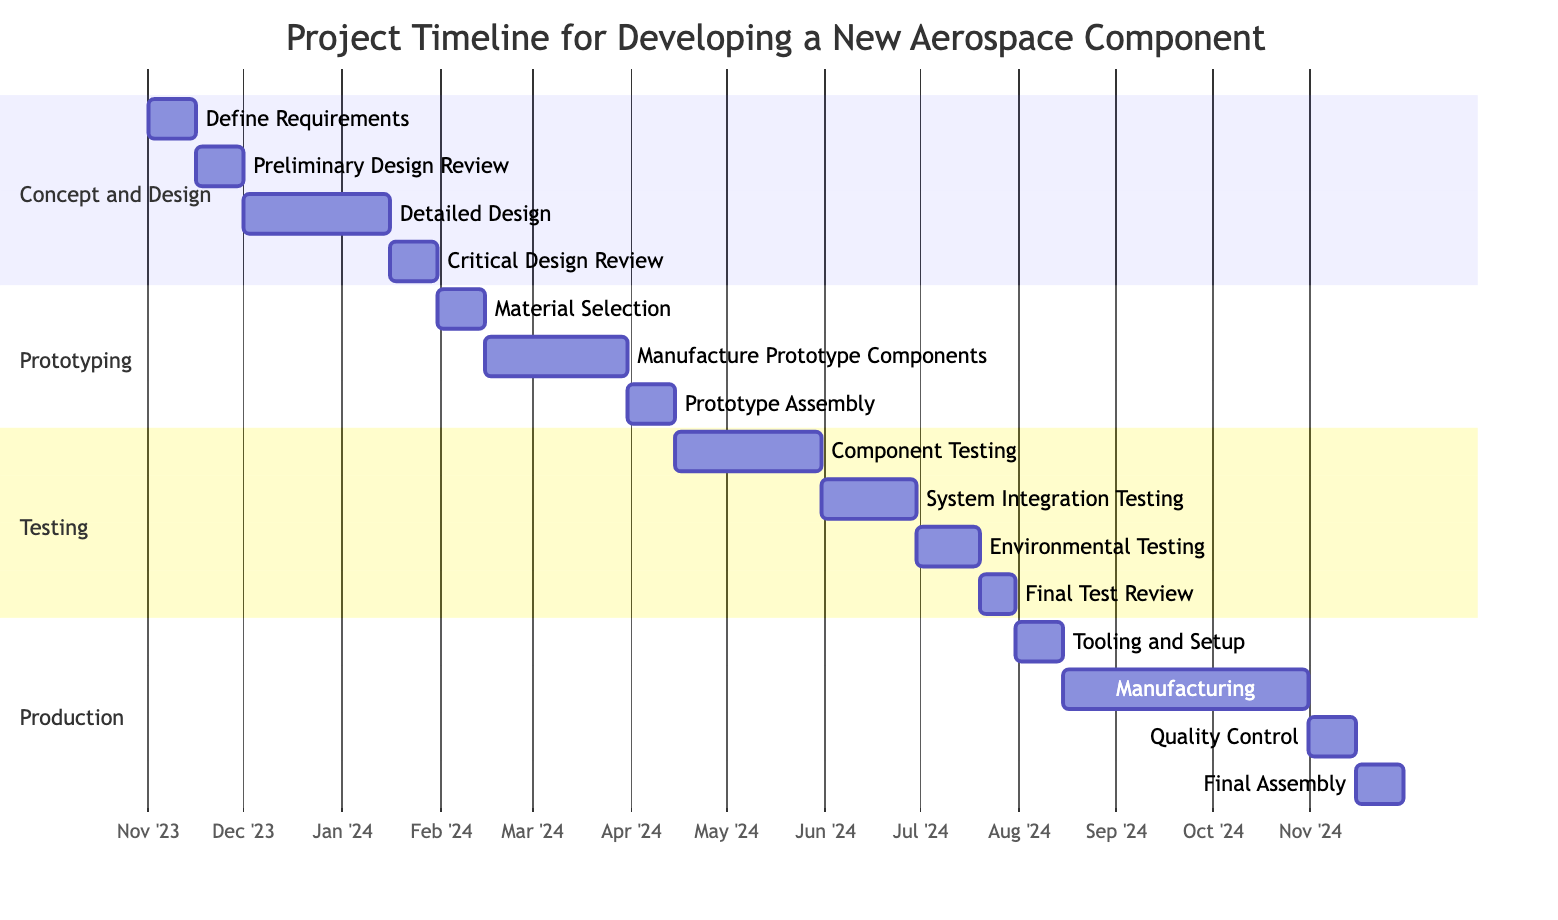What's the duration of the "Define Requirements" task? The "Define Requirements" task starts on November 1, 2023, and ends on November 15, 2023. The duration is calculated as the difference between these two dates, which is 15 days.
Answer: 15 days What task follows "Material Selection" in the prototyping phase? In the prototyping phase, "Material Selection" is followed by "Manufacture Prototype Components." This is visually indicated as "Manufacture Prototype Components" starts after "Material Selection" is completed.
Answer: Manufacture Prototype Components How many tasks are in the Testing phase? The Testing phase includes four tasks: "Component Testing," "System Integration Testing," "Environmental Testing," and "Final Test Review." Counting these tasks gives a total of four tasks in the Testing phase.
Answer: 4 tasks What is the end date of the "Manufacturing" task? The "Manufacturing" task starts on August 16, 2024, and ends on October 31, 2024. The end date is shown directly in the diagram next to the task name.
Answer: October 31, 2024 Which task completes right before "Tooling and Setup" begins? "Final Test Review" is the task that completes just before "Tooling and Setup" begins. This is observed as "Tooling and Setup" starts after "Final Test Review" finishes.
Answer: Final Test Review What is the total duration of the Prototyping phase? The Prototyping phase consists of three tasks: "Material Selection" (15 days), "Manufacture Prototype Components" (45 days), and "Prototype Assembly" (15 days). The total duration is calculated by adding these durations (15 + 45 + 15 = 75 days). The total time elapsed for the Prototyping phase thus spans from February 1 to April 15, 2024.
Answer: 75 days How many days do the testing tasks take in total from the start of "Component Testing" to the end of "Final Test Review"? The tasks in the Testing phase take a total of 107 days. The breakdown is as follows: "Component Testing" (46 days), "System Integration Testing" (30 days), "Environmental Testing" (20 days), and "Final Test Review" (11 days). Adding these durations gives 46 + 30 + 20 + 11 = 107 days.
Answer: 107 days What is the task that has the longest duration in the Gantt chart? The task with the longest duration is "Manufacturing," which lasts for 77 days, starting from August 16, 2024, to October 31, 2024. The duration is visually confirmed by counting the days indicated in the diagram.
Answer: Manufacturing Which phase does "Critical Design Review" belong to? "Critical Design Review" is part of the "Concept and Design" phase, as it is listed under that phase in the Gantt chart. This is based on the hierarchical structure present in the diagram where phases encompass their respective tasks.
Answer: Concept and Design 